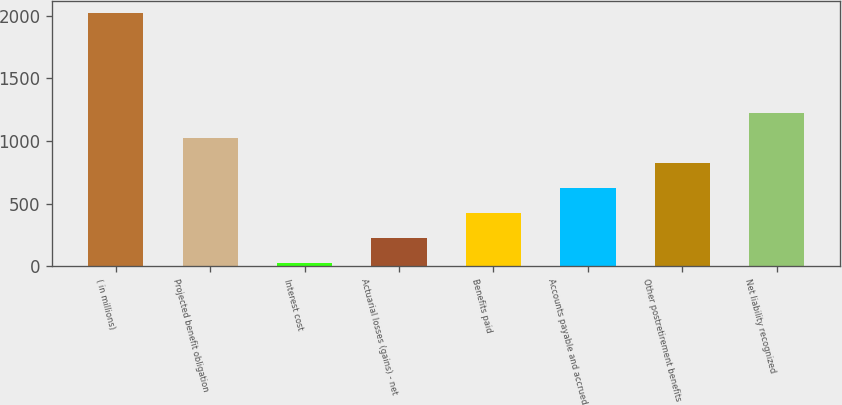Convert chart to OTSL. <chart><loc_0><loc_0><loc_500><loc_500><bar_chart><fcel>( in millions)<fcel>Projected benefit obligation<fcel>Interest cost<fcel>Actuarial losses (gains) - net<fcel>Benefits paid<fcel>Accounts payable and accrued<fcel>Other postretirement benefits<fcel>Net liability recognized<nl><fcel>2018<fcel>1021<fcel>24<fcel>223.4<fcel>422.8<fcel>622.2<fcel>821.6<fcel>1220.4<nl></chart> 